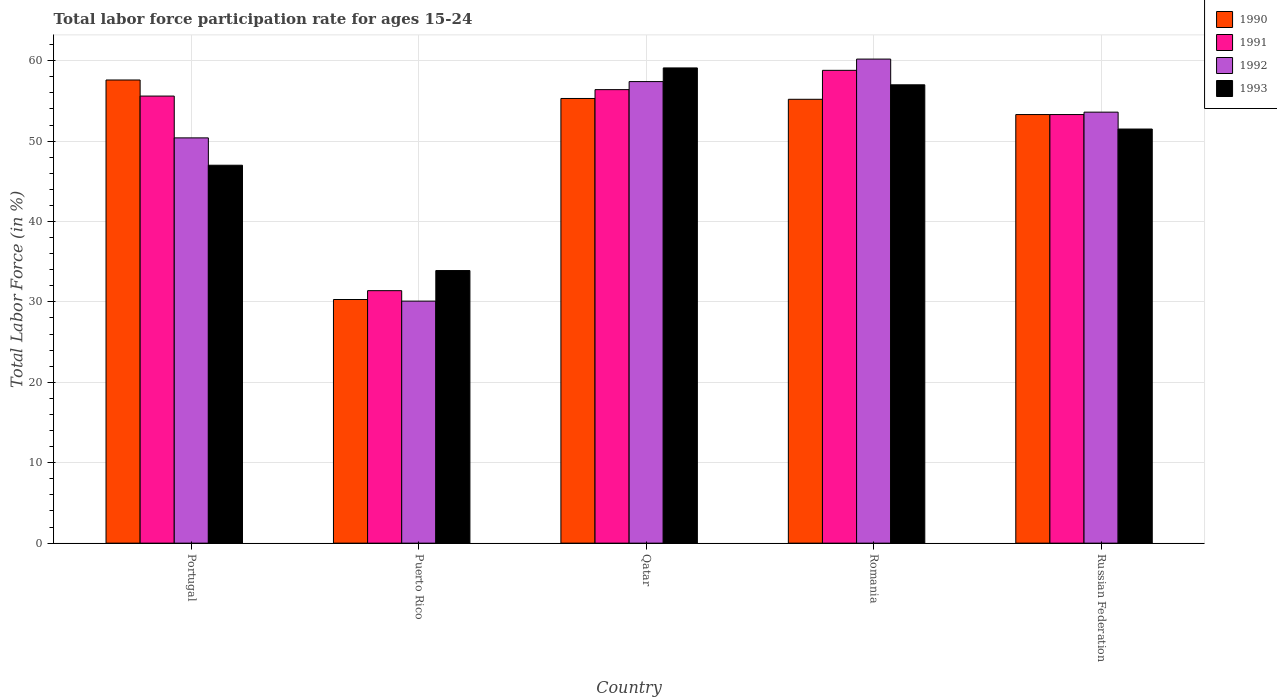Are the number of bars on each tick of the X-axis equal?
Keep it short and to the point. Yes. How many bars are there on the 5th tick from the right?
Ensure brevity in your answer.  4. What is the label of the 4th group of bars from the left?
Your response must be concise. Romania. In how many cases, is the number of bars for a given country not equal to the number of legend labels?
Give a very brief answer. 0. What is the labor force participation rate in 1993 in Puerto Rico?
Provide a succinct answer. 33.9. Across all countries, what is the maximum labor force participation rate in 1990?
Provide a succinct answer. 57.6. Across all countries, what is the minimum labor force participation rate in 1992?
Provide a short and direct response. 30.1. In which country was the labor force participation rate in 1991 maximum?
Your answer should be compact. Romania. In which country was the labor force participation rate in 1992 minimum?
Your answer should be very brief. Puerto Rico. What is the total labor force participation rate in 1992 in the graph?
Your answer should be very brief. 251.7. What is the difference between the labor force participation rate in 1992 in Portugal and that in Puerto Rico?
Your answer should be very brief. 20.3. What is the difference between the labor force participation rate in 1992 in Romania and the labor force participation rate in 1990 in Russian Federation?
Your answer should be very brief. 6.9. What is the average labor force participation rate in 1992 per country?
Keep it short and to the point. 50.34. What is the difference between the labor force participation rate of/in 1991 and labor force participation rate of/in 1992 in Portugal?
Offer a very short reply. 5.2. In how many countries, is the labor force participation rate in 1993 greater than 30 %?
Keep it short and to the point. 5. What is the ratio of the labor force participation rate in 1991 in Puerto Rico to that in Romania?
Keep it short and to the point. 0.53. Is the labor force participation rate in 1993 in Qatar less than that in Russian Federation?
Provide a short and direct response. No. Is the difference between the labor force participation rate in 1991 in Portugal and Romania greater than the difference between the labor force participation rate in 1992 in Portugal and Romania?
Give a very brief answer. Yes. What is the difference between the highest and the second highest labor force participation rate in 1992?
Offer a very short reply. -2.8. What is the difference between the highest and the lowest labor force participation rate in 1990?
Make the answer very short. 27.3. In how many countries, is the labor force participation rate in 1993 greater than the average labor force participation rate in 1993 taken over all countries?
Make the answer very short. 3. Is the sum of the labor force participation rate in 1990 in Puerto Rico and Qatar greater than the maximum labor force participation rate in 1993 across all countries?
Offer a terse response. Yes. What does the 3rd bar from the left in Puerto Rico represents?
Provide a short and direct response. 1992. What does the 4th bar from the right in Qatar represents?
Your response must be concise. 1990. How many bars are there?
Keep it short and to the point. 20. Are all the bars in the graph horizontal?
Your response must be concise. No. How many countries are there in the graph?
Keep it short and to the point. 5. Does the graph contain any zero values?
Provide a short and direct response. No. Does the graph contain grids?
Your answer should be very brief. Yes. How are the legend labels stacked?
Your answer should be compact. Vertical. What is the title of the graph?
Offer a very short reply. Total labor force participation rate for ages 15-24. What is the label or title of the Y-axis?
Give a very brief answer. Total Labor Force (in %). What is the Total Labor Force (in %) of 1990 in Portugal?
Your answer should be very brief. 57.6. What is the Total Labor Force (in %) in 1991 in Portugal?
Your response must be concise. 55.6. What is the Total Labor Force (in %) of 1992 in Portugal?
Provide a short and direct response. 50.4. What is the Total Labor Force (in %) of 1990 in Puerto Rico?
Provide a succinct answer. 30.3. What is the Total Labor Force (in %) of 1991 in Puerto Rico?
Provide a short and direct response. 31.4. What is the Total Labor Force (in %) of 1992 in Puerto Rico?
Ensure brevity in your answer.  30.1. What is the Total Labor Force (in %) in 1993 in Puerto Rico?
Ensure brevity in your answer.  33.9. What is the Total Labor Force (in %) in 1990 in Qatar?
Provide a succinct answer. 55.3. What is the Total Labor Force (in %) in 1991 in Qatar?
Your response must be concise. 56.4. What is the Total Labor Force (in %) in 1992 in Qatar?
Provide a short and direct response. 57.4. What is the Total Labor Force (in %) of 1993 in Qatar?
Provide a succinct answer. 59.1. What is the Total Labor Force (in %) of 1990 in Romania?
Provide a short and direct response. 55.2. What is the Total Labor Force (in %) in 1991 in Romania?
Offer a very short reply. 58.8. What is the Total Labor Force (in %) of 1992 in Romania?
Ensure brevity in your answer.  60.2. What is the Total Labor Force (in %) of 1993 in Romania?
Offer a terse response. 57. What is the Total Labor Force (in %) of 1990 in Russian Federation?
Your answer should be very brief. 53.3. What is the Total Labor Force (in %) of 1991 in Russian Federation?
Keep it short and to the point. 53.3. What is the Total Labor Force (in %) in 1992 in Russian Federation?
Ensure brevity in your answer.  53.6. What is the Total Labor Force (in %) of 1993 in Russian Federation?
Offer a very short reply. 51.5. Across all countries, what is the maximum Total Labor Force (in %) of 1990?
Your answer should be compact. 57.6. Across all countries, what is the maximum Total Labor Force (in %) of 1991?
Your answer should be very brief. 58.8. Across all countries, what is the maximum Total Labor Force (in %) of 1992?
Offer a very short reply. 60.2. Across all countries, what is the maximum Total Labor Force (in %) in 1993?
Ensure brevity in your answer.  59.1. Across all countries, what is the minimum Total Labor Force (in %) in 1990?
Make the answer very short. 30.3. Across all countries, what is the minimum Total Labor Force (in %) in 1991?
Your response must be concise. 31.4. Across all countries, what is the minimum Total Labor Force (in %) in 1992?
Provide a succinct answer. 30.1. Across all countries, what is the minimum Total Labor Force (in %) in 1993?
Provide a succinct answer. 33.9. What is the total Total Labor Force (in %) in 1990 in the graph?
Provide a short and direct response. 251.7. What is the total Total Labor Force (in %) in 1991 in the graph?
Keep it short and to the point. 255.5. What is the total Total Labor Force (in %) of 1992 in the graph?
Give a very brief answer. 251.7. What is the total Total Labor Force (in %) in 1993 in the graph?
Keep it short and to the point. 248.5. What is the difference between the Total Labor Force (in %) of 1990 in Portugal and that in Puerto Rico?
Provide a succinct answer. 27.3. What is the difference between the Total Labor Force (in %) in 1991 in Portugal and that in Puerto Rico?
Keep it short and to the point. 24.2. What is the difference between the Total Labor Force (in %) of 1992 in Portugal and that in Puerto Rico?
Provide a short and direct response. 20.3. What is the difference between the Total Labor Force (in %) in 1990 in Portugal and that in Qatar?
Give a very brief answer. 2.3. What is the difference between the Total Labor Force (in %) in 1993 in Portugal and that in Qatar?
Make the answer very short. -12.1. What is the difference between the Total Labor Force (in %) of 1991 in Portugal and that in Romania?
Provide a short and direct response. -3.2. What is the difference between the Total Labor Force (in %) of 1990 in Portugal and that in Russian Federation?
Ensure brevity in your answer.  4.3. What is the difference between the Total Labor Force (in %) of 1991 in Portugal and that in Russian Federation?
Offer a very short reply. 2.3. What is the difference between the Total Labor Force (in %) of 1992 in Portugal and that in Russian Federation?
Provide a succinct answer. -3.2. What is the difference between the Total Labor Force (in %) of 1990 in Puerto Rico and that in Qatar?
Ensure brevity in your answer.  -25. What is the difference between the Total Labor Force (in %) of 1992 in Puerto Rico and that in Qatar?
Give a very brief answer. -27.3. What is the difference between the Total Labor Force (in %) in 1993 in Puerto Rico and that in Qatar?
Provide a short and direct response. -25.2. What is the difference between the Total Labor Force (in %) in 1990 in Puerto Rico and that in Romania?
Offer a terse response. -24.9. What is the difference between the Total Labor Force (in %) in 1991 in Puerto Rico and that in Romania?
Keep it short and to the point. -27.4. What is the difference between the Total Labor Force (in %) of 1992 in Puerto Rico and that in Romania?
Offer a terse response. -30.1. What is the difference between the Total Labor Force (in %) in 1993 in Puerto Rico and that in Romania?
Make the answer very short. -23.1. What is the difference between the Total Labor Force (in %) in 1991 in Puerto Rico and that in Russian Federation?
Keep it short and to the point. -21.9. What is the difference between the Total Labor Force (in %) in 1992 in Puerto Rico and that in Russian Federation?
Your answer should be very brief. -23.5. What is the difference between the Total Labor Force (in %) of 1993 in Puerto Rico and that in Russian Federation?
Your response must be concise. -17.6. What is the difference between the Total Labor Force (in %) of 1990 in Qatar and that in Romania?
Keep it short and to the point. 0.1. What is the difference between the Total Labor Force (in %) in 1991 in Qatar and that in Romania?
Offer a terse response. -2.4. What is the difference between the Total Labor Force (in %) in 1992 in Qatar and that in Russian Federation?
Your answer should be very brief. 3.8. What is the difference between the Total Labor Force (in %) in 1993 in Qatar and that in Russian Federation?
Offer a terse response. 7.6. What is the difference between the Total Labor Force (in %) of 1990 in Romania and that in Russian Federation?
Make the answer very short. 1.9. What is the difference between the Total Labor Force (in %) of 1991 in Romania and that in Russian Federation?
Provide a short and direct response. 5.5. What is the difference between the Total Labor Force (in %) in 1992 in Romania and that in Russian Federation?
Provide a short and direct response. 6.6. What is the difference between the Total Labor Force (in %) of 1993 in Romania and that in Russian Federation?
Your response must be concise. 5.5. What is the difference between the Total Labor Force (in %) in 1990 in Portugal and the Total Labor Force (in %) in 1991 in Puerto Rico?
Provide a short and direct response. 26.2. What is the difference between the Total Labor Force (in %) in 1990 in Portugal and the Total Labor Force (in %) in 1992 in Puerto Rico?
Give a very brief answer. 27.5. What is the difference between the Total Labor Force (in %) of 1990 in Portugal and the Total Labor Force (in %) of 1993 in Puerto Rico?
Your answer should be compact. 23.7. What is the difference between the Total Labor Force (in %) of 1991 in Portugal and the Total Labor Force (in %) of 1993 in Puerto Rico?
Provide a short and direct response. 21.7. What is the difference between the Total Labor Force (in %) in 1992 in Portugal and the Total Labor Force (in %) in 1993 in Qatar?
Your response must be concise. -8.7. What is the difference between the Total Labor Force (in %) of 1990 in Portugal and the Total Labor Force (in %) of 1993 in Romania?
Offer a very short reply. 0.6. What is the difference between the Total Labor Force (in %) of 1991 in Portugal and the Total Labor Force (in %) of 1992 in Romania?
Your response must be concise. -4.6. What is the difference between the Total Labor Force (in %) in 1990 in Portugal and the Total Labor Force (in %) in 1991 in Russian Federation?
Your answer should be compact. 4.3. What is the difference between the Total Labor Force (in %) of 1990 in Portugal and the Total Labor Force (in %) of 1992 in Russian Federation?
Your response must be concise. 4. What is the difference between the Total Labor Force (in %) in 1992 in Portugal and the Total Labor Force (in %) in 1993 in Russian Federation?
Ensure brevity in your answer.  -1.1. What is the difference between the Total Labor Force (in %) in 1990 in Puerto Rico and the Total Labor Force (in %) in 1991 in Qatar?
Your answer should be compact. -26.1. What is the difference between the Total Labor Force (in %) of 1990 in Puerto Rico and the Total Labor Force (in %) of 1992 in Qatar?
Keep it short and to the point. -27.1. What is the difference between the Total Labor Force (in %) in 1990 in Puerto Rico and the Total Labor Force (in %) in 1993 in Qatar?
Keep it short and to the point. -28.8. What is the difference between the Total Labor Force (in %) in 1991 in Puerto Rico and the Total Labor Force (in %) in 1993 in Qatar?
Ensure brevity in your answer.  -27.7. What is the difference between the Total Labor Force (in %) in 1990 in Puerto Rico and the Total Labor Force (in %) in 1991 in Romania?
Your response must be concise. -28.5. What is the difference between the Total Labor Force (in %) in 1990 in Puerto Rico and the Total Labor Force (in %) in 1992 in Romania?
Keep it short and to the point. -29.9. What is the difference between the Total Labor Force (in %) of 1990 in Puerto Rico and the Total Labor Force (in %) of 1993 in Romania?
Your response must be concise. -26.7. What is the difference between the Total Labor Force (in %) in 1991 in Puerto Rico and the Total Labor Force (in %) in 1992 in Romania?
Keep it short and to the point. -28.8. What is the difference between the Total Labor Force (in %) in 1991 in Puerto Rico and the Total Labor Force (in %) in 1993 in Romania?
Your answer should be compact. -25.6. What is the difference between the Total Labor Force (in %) in 1992 in Puerto Rico and the Total Labor Force (in %) in 1993 in Romania?
Your answer should be compact. -26.9. What is the difference between the Total Labor Force (in %) in 1990 in Puerto Rico and the Total Labor Force (in %) in 1992 in Russian Federation?
Keep it short and to the point. -23.3. What is the difference between the Total Labor Force (in %) of 1990 in Puerto Rico and the Total Labor Force (in %) of 1993 in Russian Federation?
Your answer should be compact. -21.2. What is the difference between the Total Labor Force (in %) in 1991 in Puerto Rico and the Total Labor Force (in %) in 1992 in Russian Federation?
Your answer should be compact. -22.2. What is the difference between the Total Labor Force (in %) of 1991 in Puerto Rico and the Total Labor Force (in %) of 1993 in Russian Federation?
Offer a terse response. -20.1. What is the difference between the Total Labor Force (in %) in 1992 in Puerto Rico and the Total Labor Force (in %) in 1993 in Russian Federation?
Provide a succinct answer. -21.4. What is the difference between the Total Labor Force (in %) in 1990 in Qatar and the Total Labor Force (in %) in 1991 in Romania?
Your answer should be compact. -3.5. What is the difference between the Total Labor Force (in %) of 1990 in Qatar and the Total Labor Force (in %) of 1992 in Romania?
Your answer should be compact. -4.9. What is the difference between the Total Labor Force (in %) in 1990 in Qatar and the Total Labor Force (in %) in 1993 in Romania?
Give a very brief answer. -1.7. What is the difference between the Total Labor Force (in %) of 1990 in Qatar and the Total Labor Force (in %) of 1992 in Russian Federation?
Your response must be concise. 1.7. What is the difference between the Total Labor Force (in %) in 1990 in Qatar and the Total Labor Force (in %) in 1993 in Russian Federation?
Provide a short and direct response. 3.8. What is the difference between the Total Labor Force (in %) in 1991 in Qatar and the Total Labor Force (in %) in 1992 in Russian Federation?
Your answer should be very brief. 2.8. What is the difference between the Total Labor Force (in %) in 1992 in Qatar and the Total Labor Force (in %) in 1993 in Russian Federation?
Your response must be concise. 5.9. What is the difference between the Total Labor Force (in %) of 1990 in Romania and the Total Labor Force (in %) of 1991 in Russian Federation?
Make the answer very short. 1.9. What is the difference between the Total Labor Force (in %) in 1990 in Romania and the Total Labor Force (in %) in 1992 in Russian Federation?
Your response must be concise. 1.6. What is the difference between the Total Labor Force (in %) in 1990 in Romania and the Total Labor Force (in %) in 1993 in Russian Federation?
Offer a terse response. 3.7. What is the difference between the Total Labor Force (in %) of 1991 in Romania and the Total Labor Force (in %) of 1992 in Russian Federation?
Give a very brief answer. 5.2. What is the difference between the Total Labor Force (in %) of 1991 in Romania and the Total Labor Force (in %) of 1993 in Russian Federation?
Your answer should be compact. 7.3. What is the difference between the Total Labor Force (in %) in 1992 in Romania and the Total Labor Force (in %) in 1993 in Russian Federation?
Offer a terse response. 8.7. What is the average Total Labor Force (in %) of 1990 per country?
Offer a very short reply. 50.34. What is the average Total Labor Force (in %) of 1991 per country?
Make the answer very short. 51.1. What is the average Total Labor Force (in %) of 1992 per country?
Your answer should be compact. 50.34. What is the average Total Labor Force (in %) in 1993 per country?
Ensure brevity in your answer.  49.7. What is the difference between the Total Labor Force (in %) in 1990 and Total Labor Force (in %) in 1991 in Portugal?
Your response must be concise. 2. What is the difference between the Total Labor Force (in %) of 1990 and Total Labor Force (in %) of 1992 in Portugal?
Your answer should be compact. 7.2. What is the difference between the Total Labor Force (in %) of 1990 and Total Labor Force (in %) of 1993 in Portugal?
Keep it short and to the point. 10.6. What is the difference between the Total Labor Force (in %) in 1991 and Total Labor Force (in %) in 1993 in Portugal?
Your answer should be very brief. 8.6. What is the difference between the Total Labor Force (in %) of 1992 and Total Labor Force (in %) of 1993 in Portugal?
Give a very brief answer. 3.4. What is the difference between the Total Labor Force (in %) in 1990 and Total Labor Force (in %) in 1992 in Puerto Rico?
Provide a succinct answer. 0.2. What is the difference between the Total Labor Force (in %) in 1992 and Total Labor Force (in %) in 1993 in Puerto Rico?
Provide a short and direct response. -3.8. What is the difference between the Total Labor Force (in %) of 1990 and Total Labor Force (in %) of 1991 in Qatar?
Make the answer very short. -1.1. What is the difference between the Total Labor Force (in %) of 1990 and Total Labor Force (in %) of 1993 in Qatar?
Ensure brevity in your answer.  -3.8. What is the difference between the Total Labor Force (in %) of 1991 and Total Labor Force (in %) of 1993 in Qatar?
Offer a very short reply. -2.7. What is the difference between the Total Labor Force (in %) in 1992 and Total Labor Force (in %) in 1993 in Qatar?
Your answer should be very brief. -1.7. What is the difference between the Total Labor Force (in %) in 1990 and Total Labor Force (in %) in 1993 in Romania?
Give a very brief answer. -1.8. What is the difference between the Total Labor Force (in %) of 1991 and Total Labor Force (in %) of 1992 in Romania?
Keep it short and to the point. -1.4. What is the difference between the Total Labor Force (in %) in 1991 and Total Labor Force (in %) in 1993 in Romania?
Provide a succinct answer. 1.8. What is the difference between the Total Labor Force (in %) of 1990 and Total Labor Force (in %) of 1992 in Russian Federation?
Give a very brief answer. -0.3. What is the difference between the Total Labor Force (in %) in 1990 and Total Labor Force (in %) in 1993 in Russian Federation?
Your response must be concise. 1.8. What is the difference between the Total Labor Force (in %) in 1991 and Total Labor Force (in %) in 1992 in Russian Federation?
Keep it short and to the point. -0.3. What is the difference between the Total Labor Force (in %) in 1991 and Total Labor Force (in %) in 1993 in Russian Federation?
Your response must be concise. 1.8. What is the difference between the Total Labor Force (in %) of 1992 and Total Labor Force (in %) of 1993 in Russian Federation?
Your answer should be compact. 2.1. What is the ratio of the Total Labor Force (in %) in 1990 in Portugal to that in Puerto Rico?
Offer a terse response. 1.9. What is the ratio of the Total Labor Force (in %) in 1991 in Portugal to that in Puerto Rico?
Ensure brevity in your answer.  1.77. What is the ratio of the Total Labor Force (in %) of 1992 in Portugal to that in Puerto Rico?
Your response must be concise. 1.67. What is the ratio of the Total Labor Force (in %) of 1993 in Portugal to that in Puerto Rico?
Make the answer very short. 1.39. What is the ratio of the Total Labor Force (in %) of 1990 in Portugal to that in Qatar?
Keep it short and to the point. 1.04. What is the ratio of the Total Labor Force (in %) of 1991 in Portugal to that in Qatar?
Offer a very short reply. 0.99. What is the ratio of the Total Labor Force (in %) of 1992 in Portugal to that in Qatar?
Offer a terse response. 0.88. What is the ratio of the Total Labor Force (in %) of 1993 in Portugal to that in Qatar?
Make the answer very short. 0.8. What is the ratio of the Total Labor Force (in %) of 1990 in Portugal to that in Romania?
Your answer should be compact. 1.04. What is the ratio of the Total Labor Force (in %) in 1991 in Portugal to that in Romania?
Provide a succinct answer. 0.95. What is the ratio of the Total Labor Force (in %) of 1992 in Portugal to that in Romania?
Give a very brief answer. 0.84. What is the ratio of the Total Labor Force (in %) of 1993 in Portugal to that in Romania?
Ensure brevity in your answer.  0.82. What is the ratio of the Total Labor Force (in %) of 1990 in Portugal to that in Russian Federation?
Ensure brevity in your answer.  1.08. What is the ratio of the Total Labor Force (in %) in 1991 in Portugal to that in Russian Federation?
Your response must be concise. 1.04. What is the ratio of the Total Labor Force (in %) of 1992 in Portugal to that in Russian Federation?
Your response must be concise. 0.94. What is the ratio of the Total Labor Force (in %) in 1993 in Portugal to that in Russian Federation?
Offer a terse response. 0.91. What is the ratio of the Total Labor Force (in %) of 1990 in Puerto Rico to that in Qatar?
Offer a very short reply. 0.55. What is the ratio of the Total Labor Force (in %) of 1991 in Puerto Rico to that in Qatar?
Offer a very short reply. 0.56. What is the ratio of the Total Labor Force (in %) of 1992 in Puerto Rico to that in Qatar?
Provide a short and direct response. 0.52. What is the ratio of the Total Labor Force (in %) of 1993 in Puerto Rico to that in Qatar?
Offer a very short reply. 0.57. What is the ratio of the Total Labor Force (in %) of 1990 in Puerto Rico to that in Romania?
Offer a terse response. 0.55. What is the ratio of the Total Labor Force (in %) in 1991 in Puerto Rico to that in Romania?
Give a very brief answer. 0.53. What is the ratio of the Total Labor Force (in %) of 1993 in Puerto Rico to that in Romania?
Ensure brevity in your answer.  0.59. What is the ratio of the Total Labor Force (in %) in 1990 in Puerto Rico to that in Russian Federation?
Provide a short and direct response. 0.57. What is the ratio of the Total Labor Force (in %) of 1991 in Puerto Rico to that in Russian Federation?
Keep it short and to the point. 0.59. What is the ratio of the Total Labor Force (in %) of 1992 in Puerto Rico to that in Russian Federation?
Your response must be concise. 0.56. What is the ratio of the Total Labor Force (in %) of 1993 in Puerto Rico to that in Russian Federation?
Your response must be concise. 0.66. What is the ratio of the Total Labor Force (in %) in 1991 in Qatar to that in Romania?
Your answer should be very brief. 0.96. What is the ratio of the Total Labor Force (in %) in 1992 in Qatar to that in Romania?
Keep it short and to the point. 0.95. What is the ratio of the Total Labor Force (in %) in 1993 in Qatar to that in Romania?
Ensure brevity in your answer.  1.04. What is the ratio of the Total Labor Force (in %) in 1990 in Qatar to that in Russian Federation?
Your response must be concise. 1.04. What is the ratio of the Total Labor Force (in %) of 1991 in Qatar to that in Russian Federation?
Offer a terse response. 1.06. What is the ratio of the Total Labor Force (in %) of 1992 in Qatar to that in Russian Federation?
Your answer should be compact. 1.07. What is the ratio of the Total Labor Force (in %) in 1993 in Qatar to that in Russian Federation?
Give a very brief answer. 1.15. What is the ratio of the Total Labor Force (in %) of 1990 in Romania to that in Russian Federation?
Your answer should be compact. 1.04. What is the ratio of the Total Labor Force (in %) in 1991 in Romania to that in Russian Federation?
Provide a succinct answer. 1.1. What is the ratio of the Total Labor Force (in %) of 1992 in Romania to that in Russian Federation?
Offer a very short reply. 1.12. What is the ratio of the Total Labor Force (in %) in 1993 in Romania to that in Russian Federation?
Your response must be concise. 1.11. What is the difference between the highest and the second highest Total Labor Force (in %) of 1991?
Provide a short and direct response. 2.4. What is the difference between the highest and the second highest Total Labor Force (in %) in 1992?
Provide a short and direct response. 2.8. What is the difference between the highest and the lowest Total Labor Force (in %) of 1990?
Provide a short and direct response. 27.3. What is the difference between the highest and the lowest Total Labor Force (in %) of 1991?
Offer a terse response. 27.4. What is the difference between the highest and the lowest Total Labor Force (in %) of 1992?
Your response must be concise. 30.1. What is the difference between the highest and the lowest Total Labor Force (in %) in 1993?
Keep it short and to the point. 25.2. 